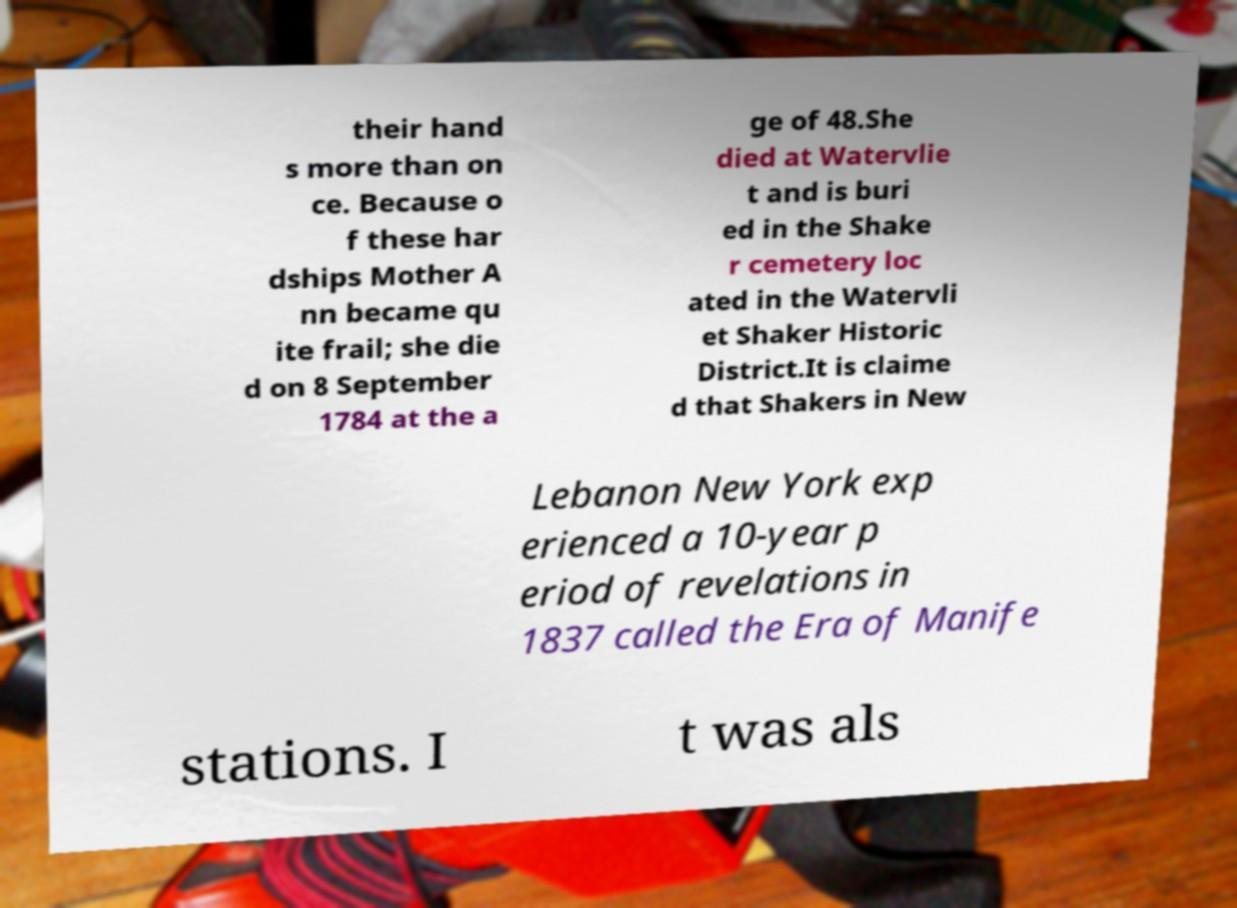For documentation purposes, I need the text within this image transcribed. Could you provide that? their hand s more than on ce. Because o f these har dships Mother A nn became qu ite frail; she die d on 8 September 1784 at the a ge of 48.She died at Watervlie t and is buri ed in the Shake r cemetery loc ated in the Watervli et Shaker Historic District.It is claime d that Shakers in New Lebanon New York exp erienced a 10-year p eriod of revelations in 1837 called the Era of Manife stations. I t was als 